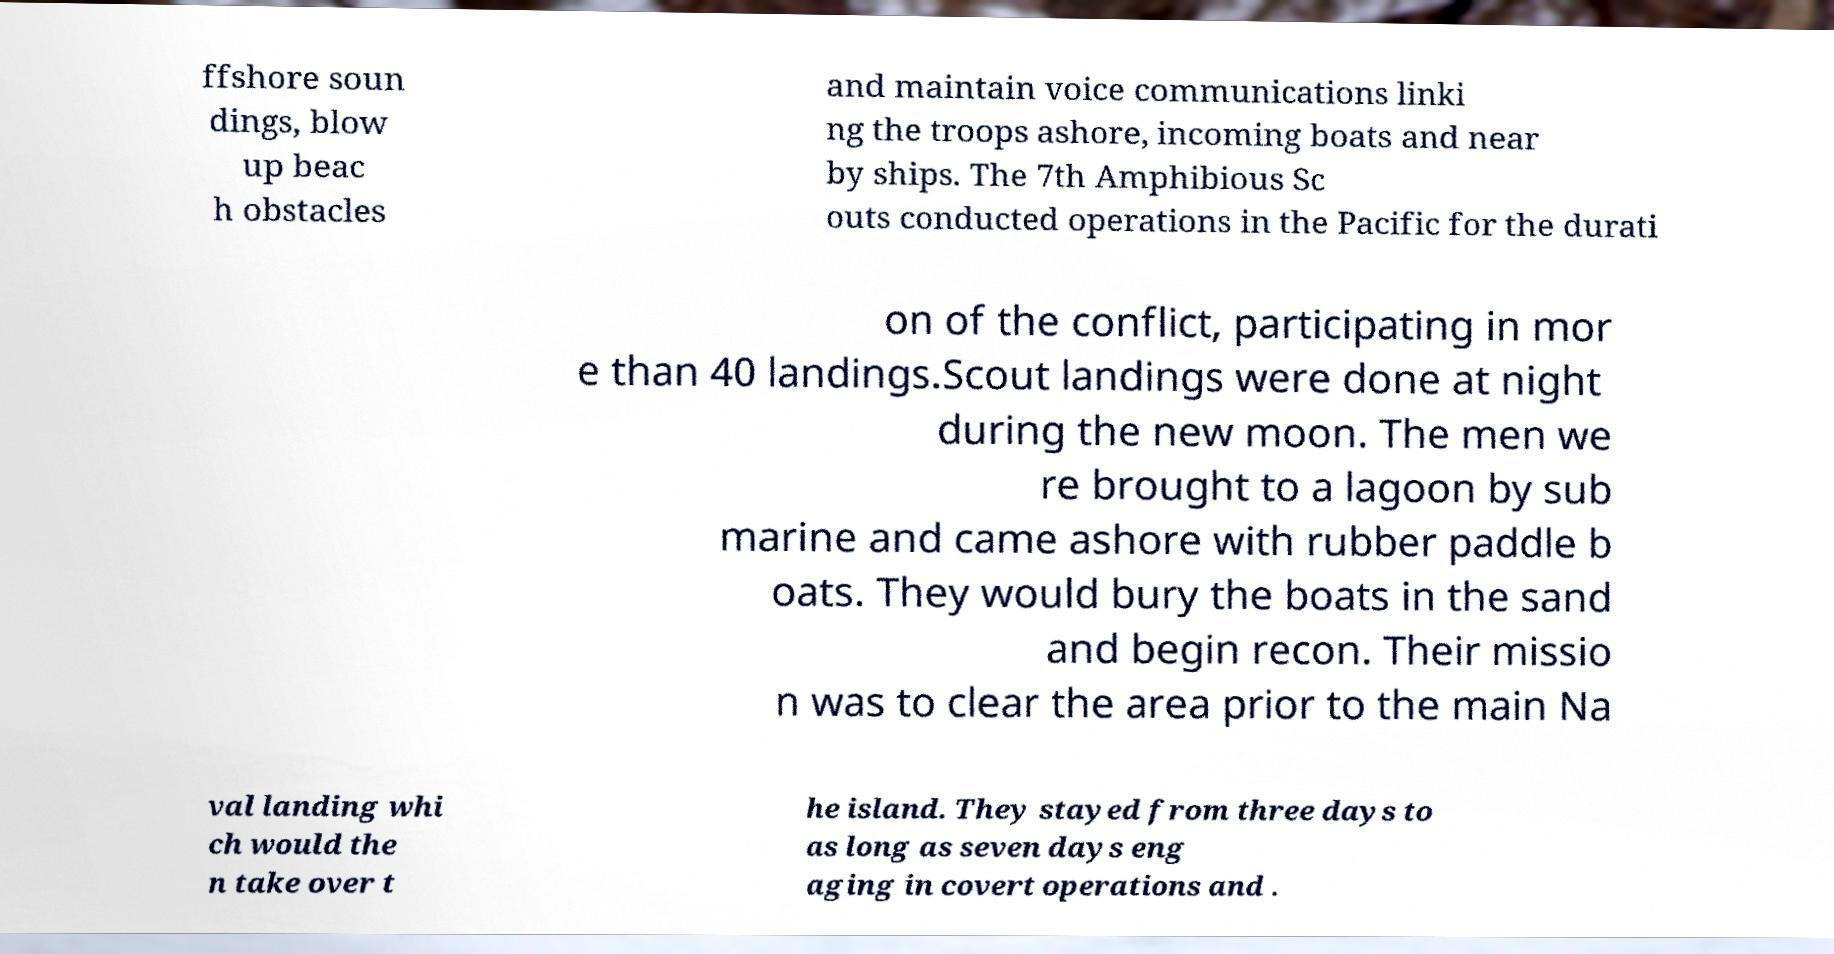Could you extract and type out the text from this image? ffshore soun dings, blow up beac h obstacles and maintain voice communications linki ng the troops ashore, incoming boats and near by ships. The 7th Amphibious Sc outs conducted operations in the Pacific for the durati on of the conflict, participating in mor e than 40 landings.Scout landings were done at night during the new moon. The men we re brought to a lagoon by sub marine and came ashore with rubber paddle b oats. They would bury the boats in the sand and begin recon. Their missio n was to clear the area prior to the main Na val landing whi ch would the n take over t he island. They stayed from three days to as long as seven days eng aging in covert operations and . 